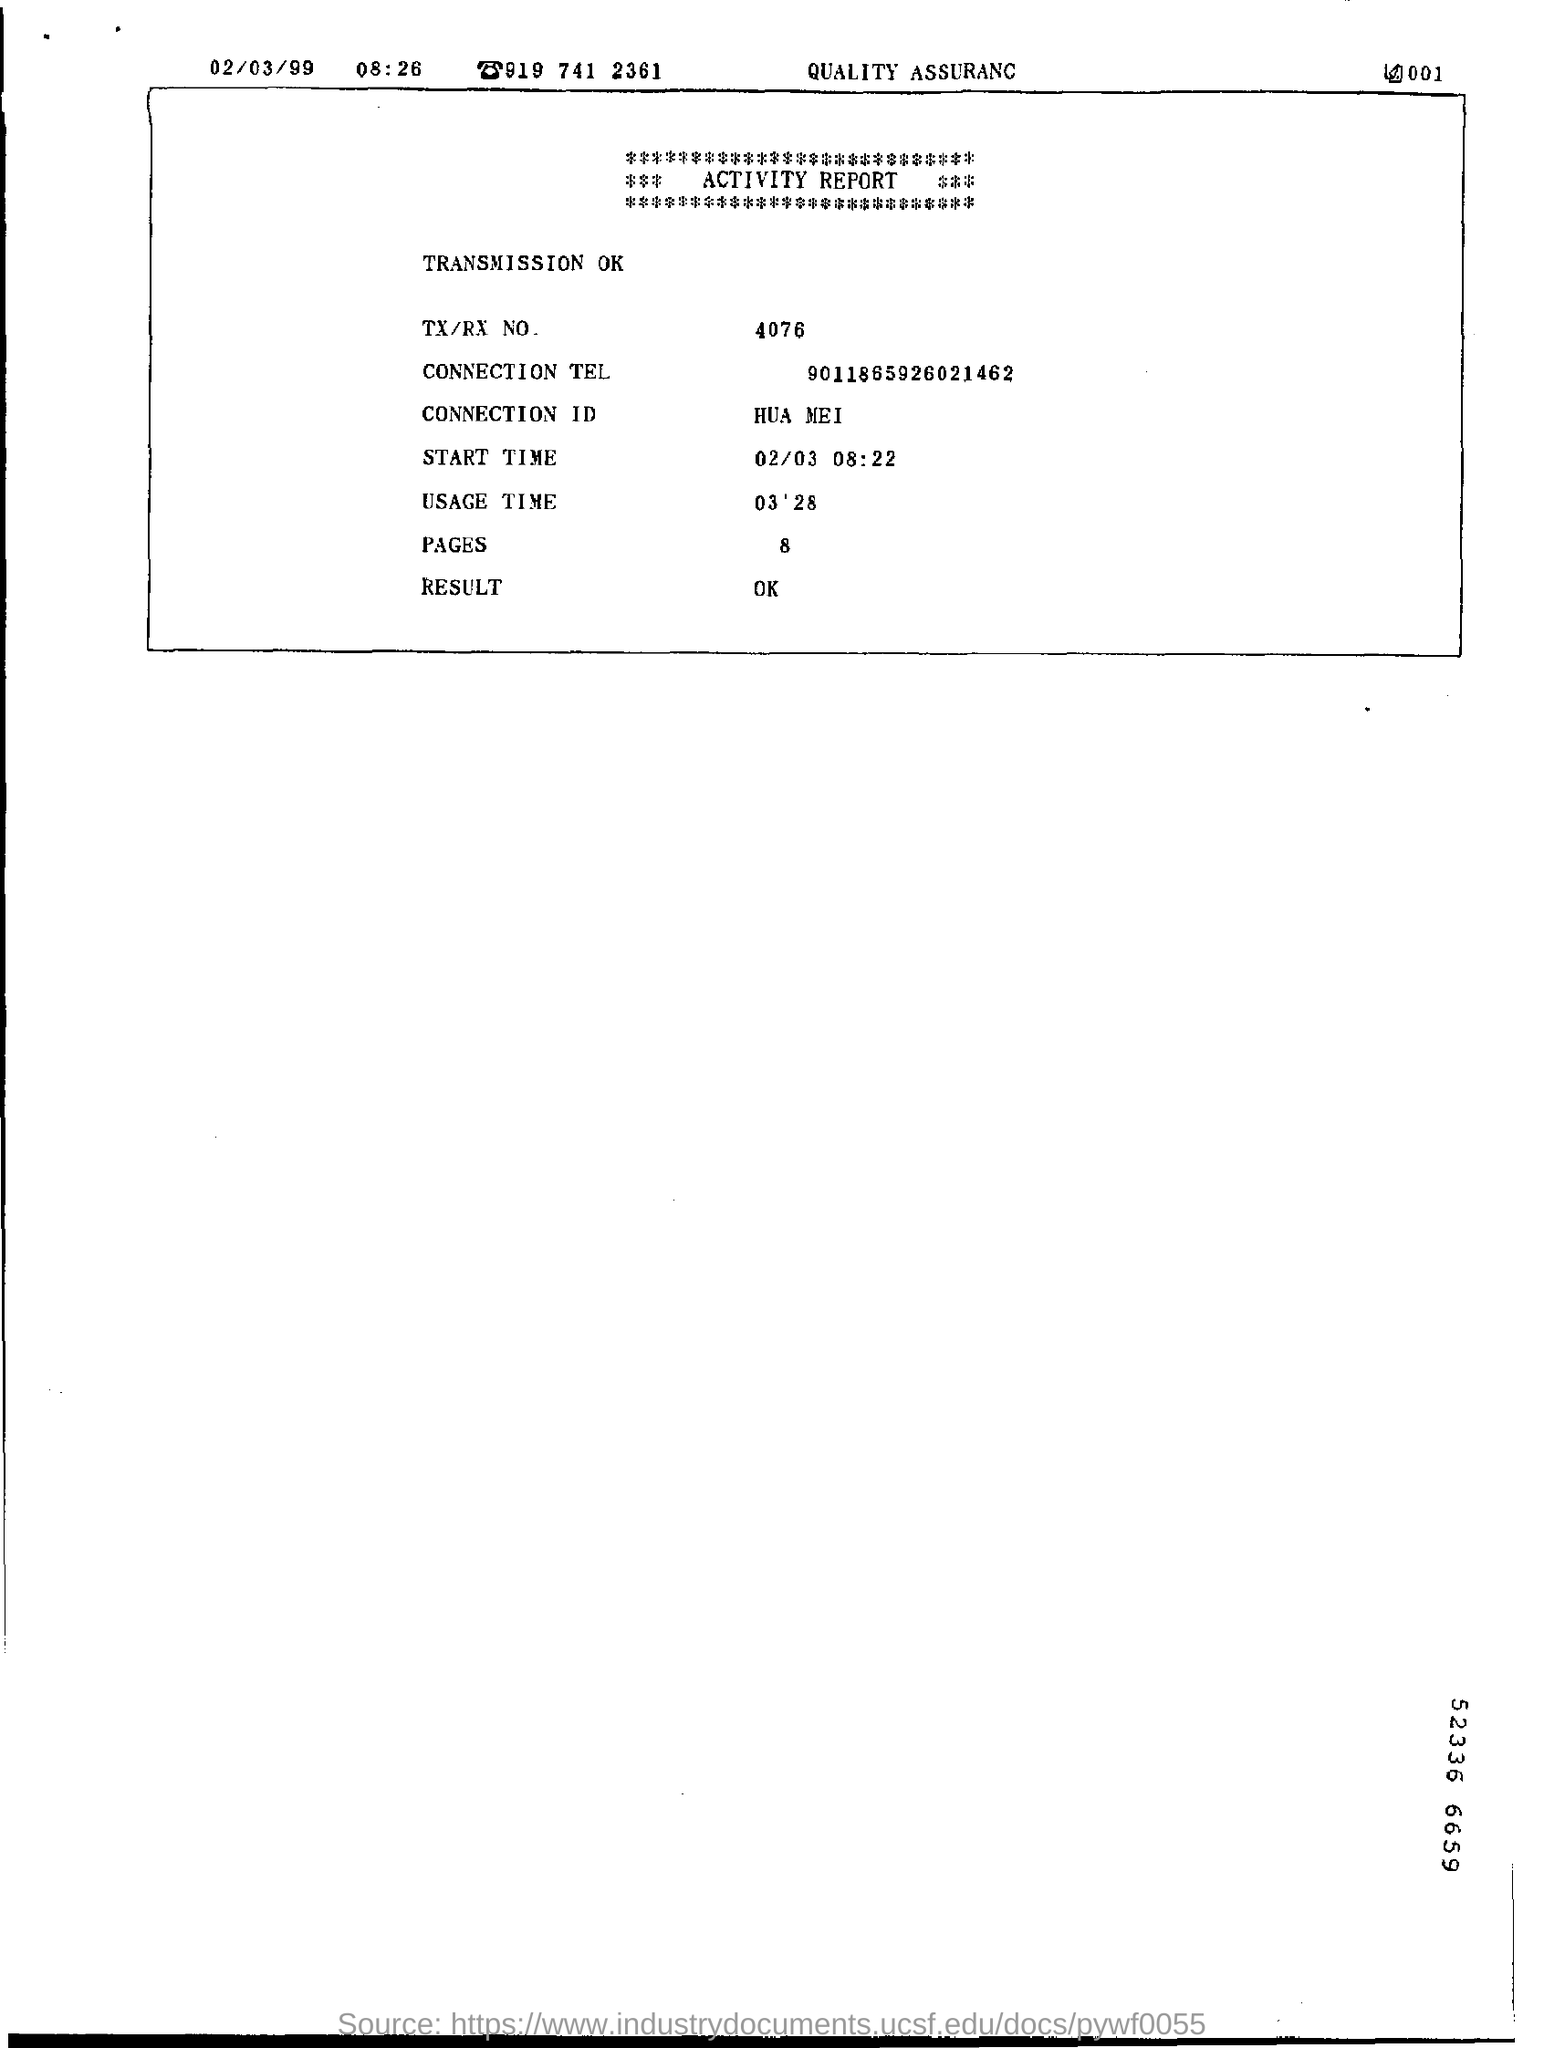List a handful of essential elements in this visual. The Connection ID mentioned in the Activity report is HUA MEI. The report provides the connection number 9011865926021462 as a reference for further inquiry or investigation. According to the Activity Report, the TX and RX values for a specific transmission are 4076. 